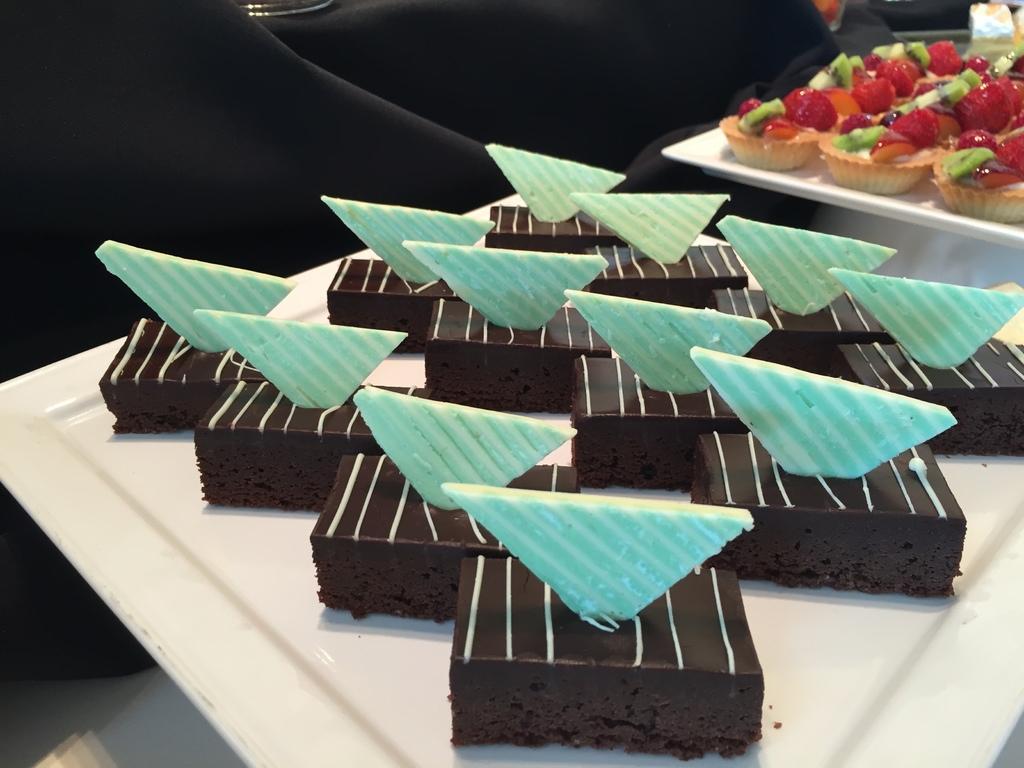How would you summarize this image in a sentence or two? In this picture we can see black and blue pastries in the white plate. Behind we can see some strawberry cupcakes. 